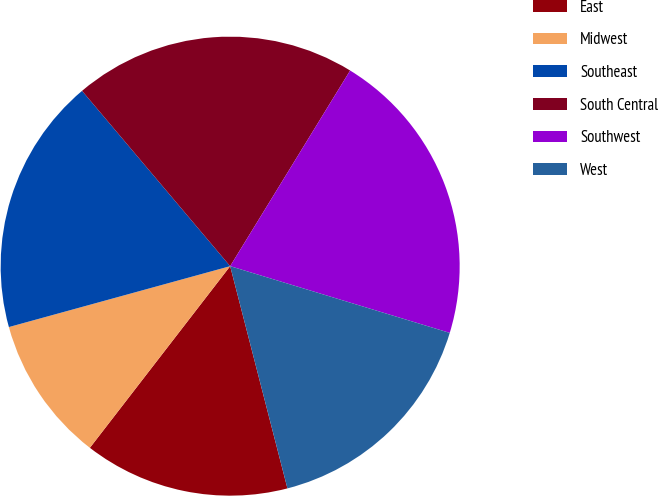Convert chart. <chart><loc_0><loc_0><loc_500><loc_500><pie_chart><fcel>East<fcel>Midwest<fcel>Southeast<fcel>South Central<fcel>Southwest<fcel>West<nl><fcel>14.48%<fcel>10.26%<fcel>18.11%<fcel>19.92%<fcel>20.94%<fcel>16.29%<nl></chart> 